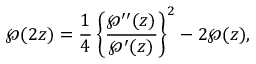<formula> <loc_0><loc_0><loc_500><loc_500>\wp ( 2 z ) = { \frac { 1 } { 4 } } \left \{ { \frac { \wp ^ { \prime \prime } ( z ) } { \wp ^ { \prime } ( z ) } } \right \} ^ { 2 } - 2 \wp ( z ) ,</formula> 